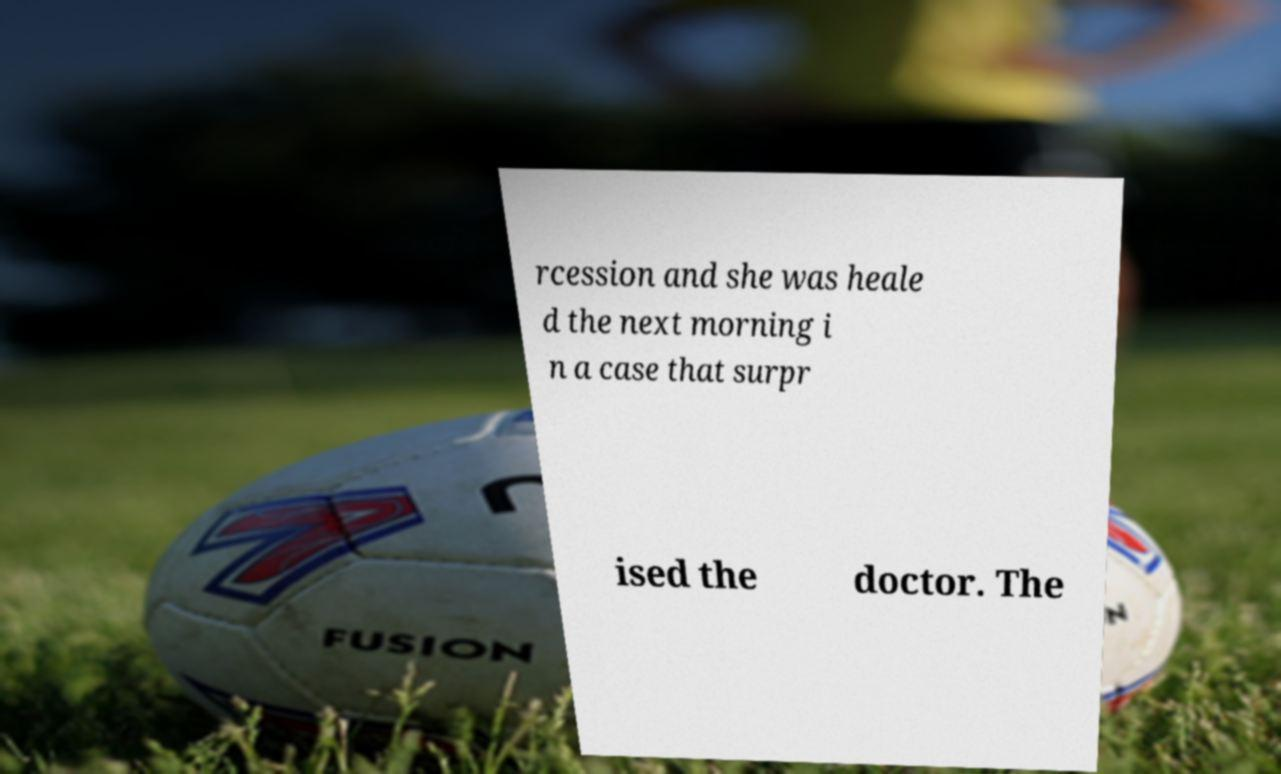For documentation purposes, I need the text within this image transcribed. Could you provide that? rcession and she was heale d the next morning i n a case that surpr ised the doctor. The 